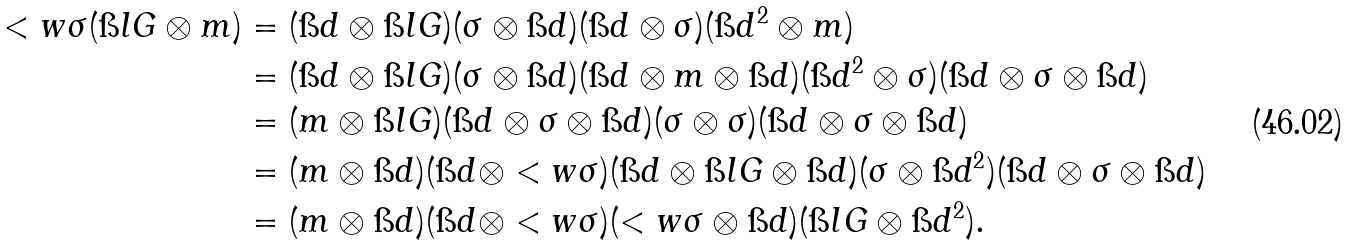<formula> <loc_0><loc_0><loc_500><loc_500>< w { \sigma } ( \i l G \otimes m ) & = ( \i d \otimes \i l G ) ( \sigma \otimes \i d ) ( \i d \otimes \sigma ) ( \i d ^ { 2 } \otimes m ) \\ & = ( \i d \otimes \i l G ) ( \sigma \otimes \i d ) ( \i d \otimes m \otimes \i d ) ( \i d ^ { 2 } \otimes \sigma ) ( \i d \otimes \sigma \otimes \i d ) \\ & = ( m \otimes \i l G ) ( \i d \otimes \sigma \otimes \i d ) ( \sigma \otimes \sigma ) ( \i d \otimes \sigma \otimes \i d ) \\ & = ( m \otimes \i d ) ( \i d \otimes < w { \sigma } ) ( \i d \otimes \i l G \otimes \i d ) ( \sigma \otimes \i d ^ { 2 } ) ( \i d \otimes \sigma \otimes \i d ) \\ & = ( m \otimes \i d ) ( \i d \otimes < w { \sigma } ) ( < w { \sigma } \otimes \i d ) ( \i l G \otimes \i d ^ { 2 } ) .</formula> 